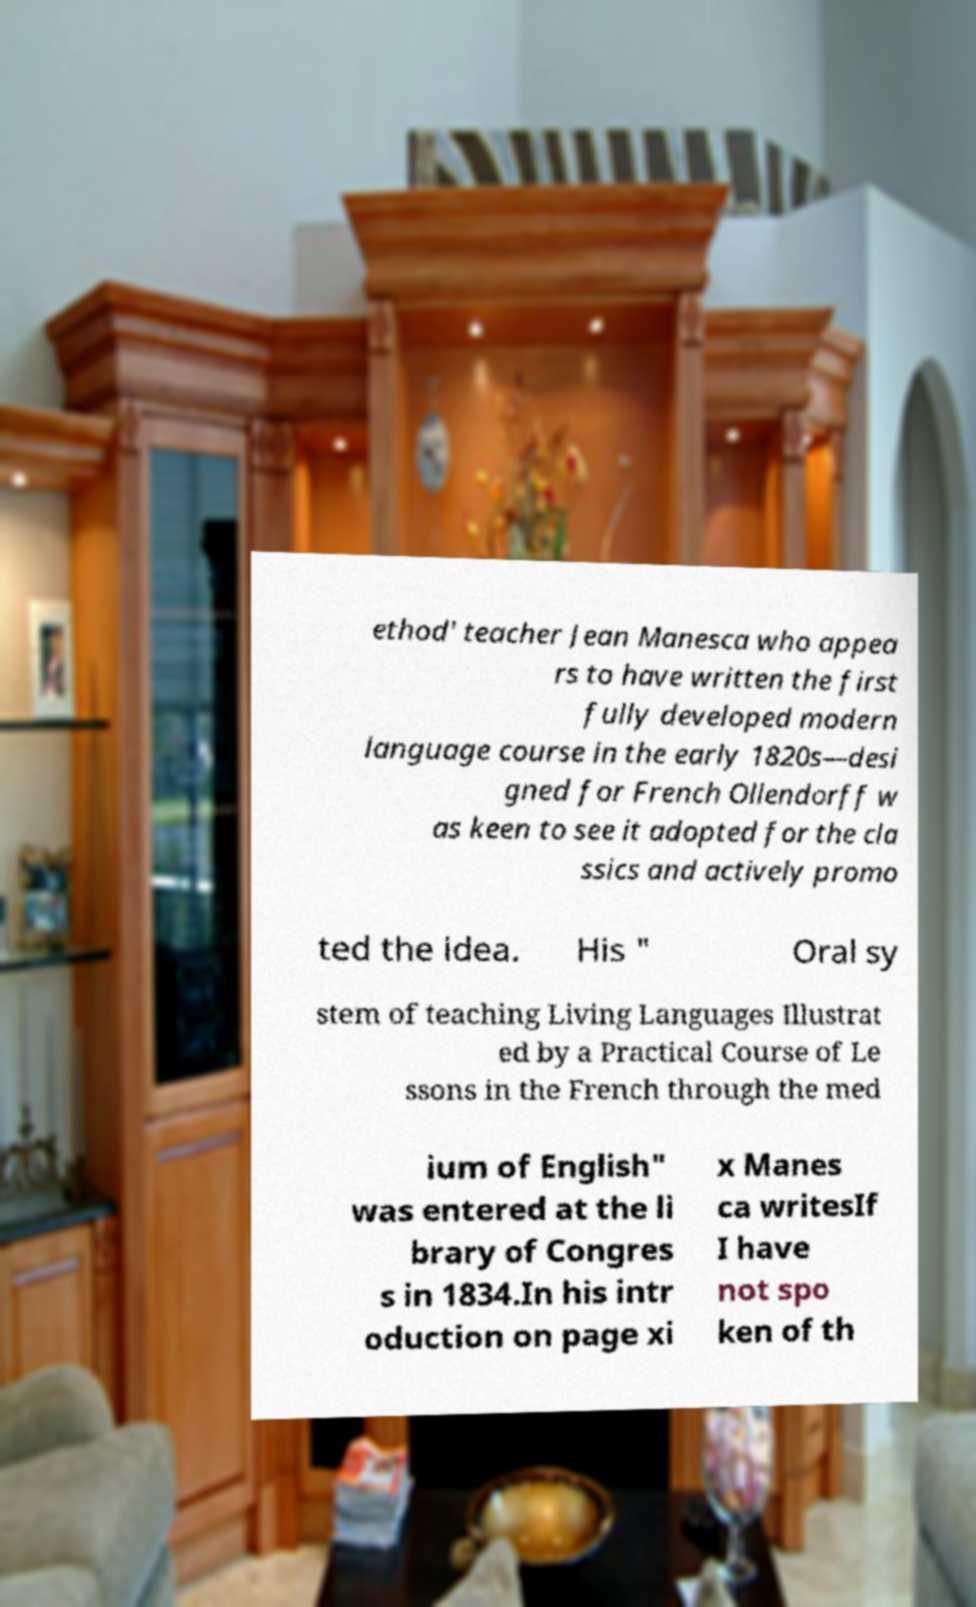I need the written content from this picture converted into text. Can you do that? ethod' teacher Jean Manesca who appea rs to have written the first fully developed modern language course in the early 1820s—desi gned for French Ollendorff w as keen to see it adopted for the cla ssics and actively promo ted the idea. His " Oral sy stem of teaching Living Languages Illustrat ed by a Practical Course of Le ssons in the French through the med ium of English" was entered at the li brary of Congres s in 1834.In his intr oduction on page xi x Manes ca writesIf I have not spo ken of th 